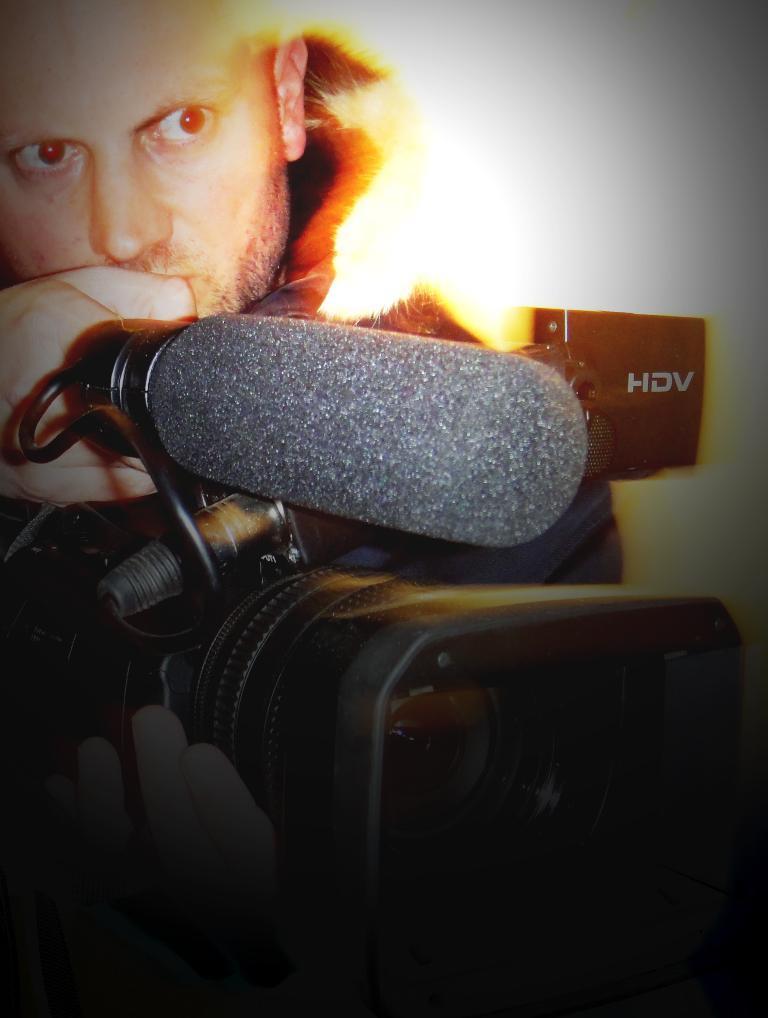In one or two sentences, can you explain what this image depicts? In this image, There is a man holding a camera which is in black color, In the rightsize there is a black color object on that HIV is written. 